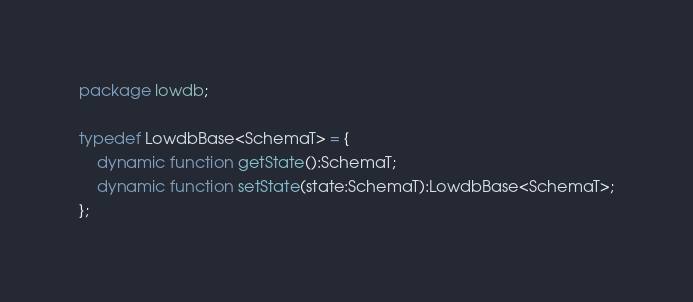Convert code to text. <code><loc_0><loc_0><loc_500><loc_500><_Haxe_>package lowdb;

typedef LowdbBase<SchemaT> = {
	dynamic function getState():SchemaT;
	dynamic function setState(state:SchemaT):LowdbBase<SchemaT>;
};</code> 